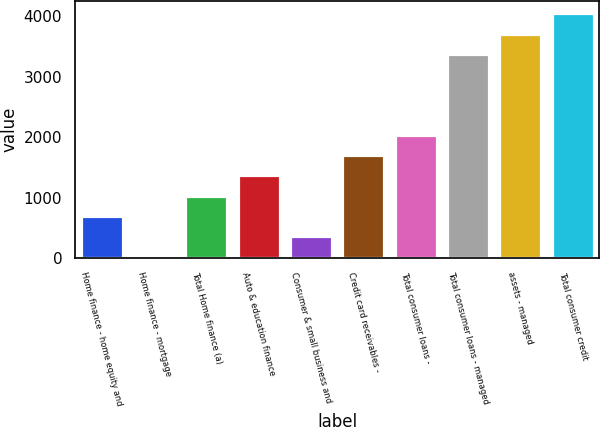<chart> <loc_0><loc_0><loc_500><loc_500><bar_chart><fcel>Home finance - home equity and<fcel>Home finance - mortgage<fcel>Total Home finance (a)<fcel>Auto & education finance<fcel>Consumer & small business and<fcel>Credit card receivables -<fcel>Total consumer loans -<fcel>Total consumer loans - managed<fcel>assets - managed<fcel>Total consumer credit<nl><fcel>696.2<fcel>26<fcel>1031.3<fcel>1366.4<fcel>361.1<fcel>1701.5<fcel>2036.6<fcel>3377<fcel>3712.1<fcel>4047.2<nl></chart> 